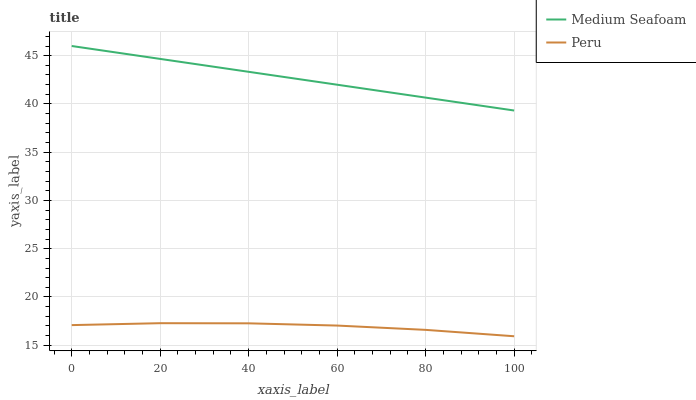Does Peru have the minimum area under the curve?
Answer yes or no. Yes. Does Medium Seafoam have the maximum area under the curve?
Answer yes or no. Yes. Does Peru have the maximum area under the curve?
Answer yes or no. No. Is Medium Seafoam the smoothest?
Answer yes or no. Yes. Is Peru the roughest?
Answer yes or no. Yes. Is Peru the smoothest?
Answer yes or no. No. Does Medium Seafoam have the highest value?
Answer yes or no. Yes. Does Peru have the highest value?
Answer yes or no. No. Is Peru less than Medium Seafoam?
Answer yes or no. Yes. Is Medium Seafoam greater than Peru?
Answer yes or no. Yes. Does Peru intersect Medium Seafoam?
Answer yes or no. No. 